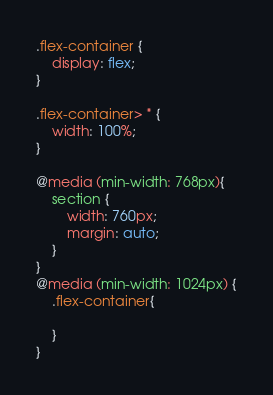<code> <loc_0><loc_0><loc_500><loc_500><_CSS_>.flex-container {
    display: flex;
}

.flex-container> * {
    width: 100%;
}

@media (min-width: 768px){
    section {
        width: 760px;
        margin: auto;
    }
}
@media (min-width: 1024px) {
    .flex-container{
        
    }
}</code> 